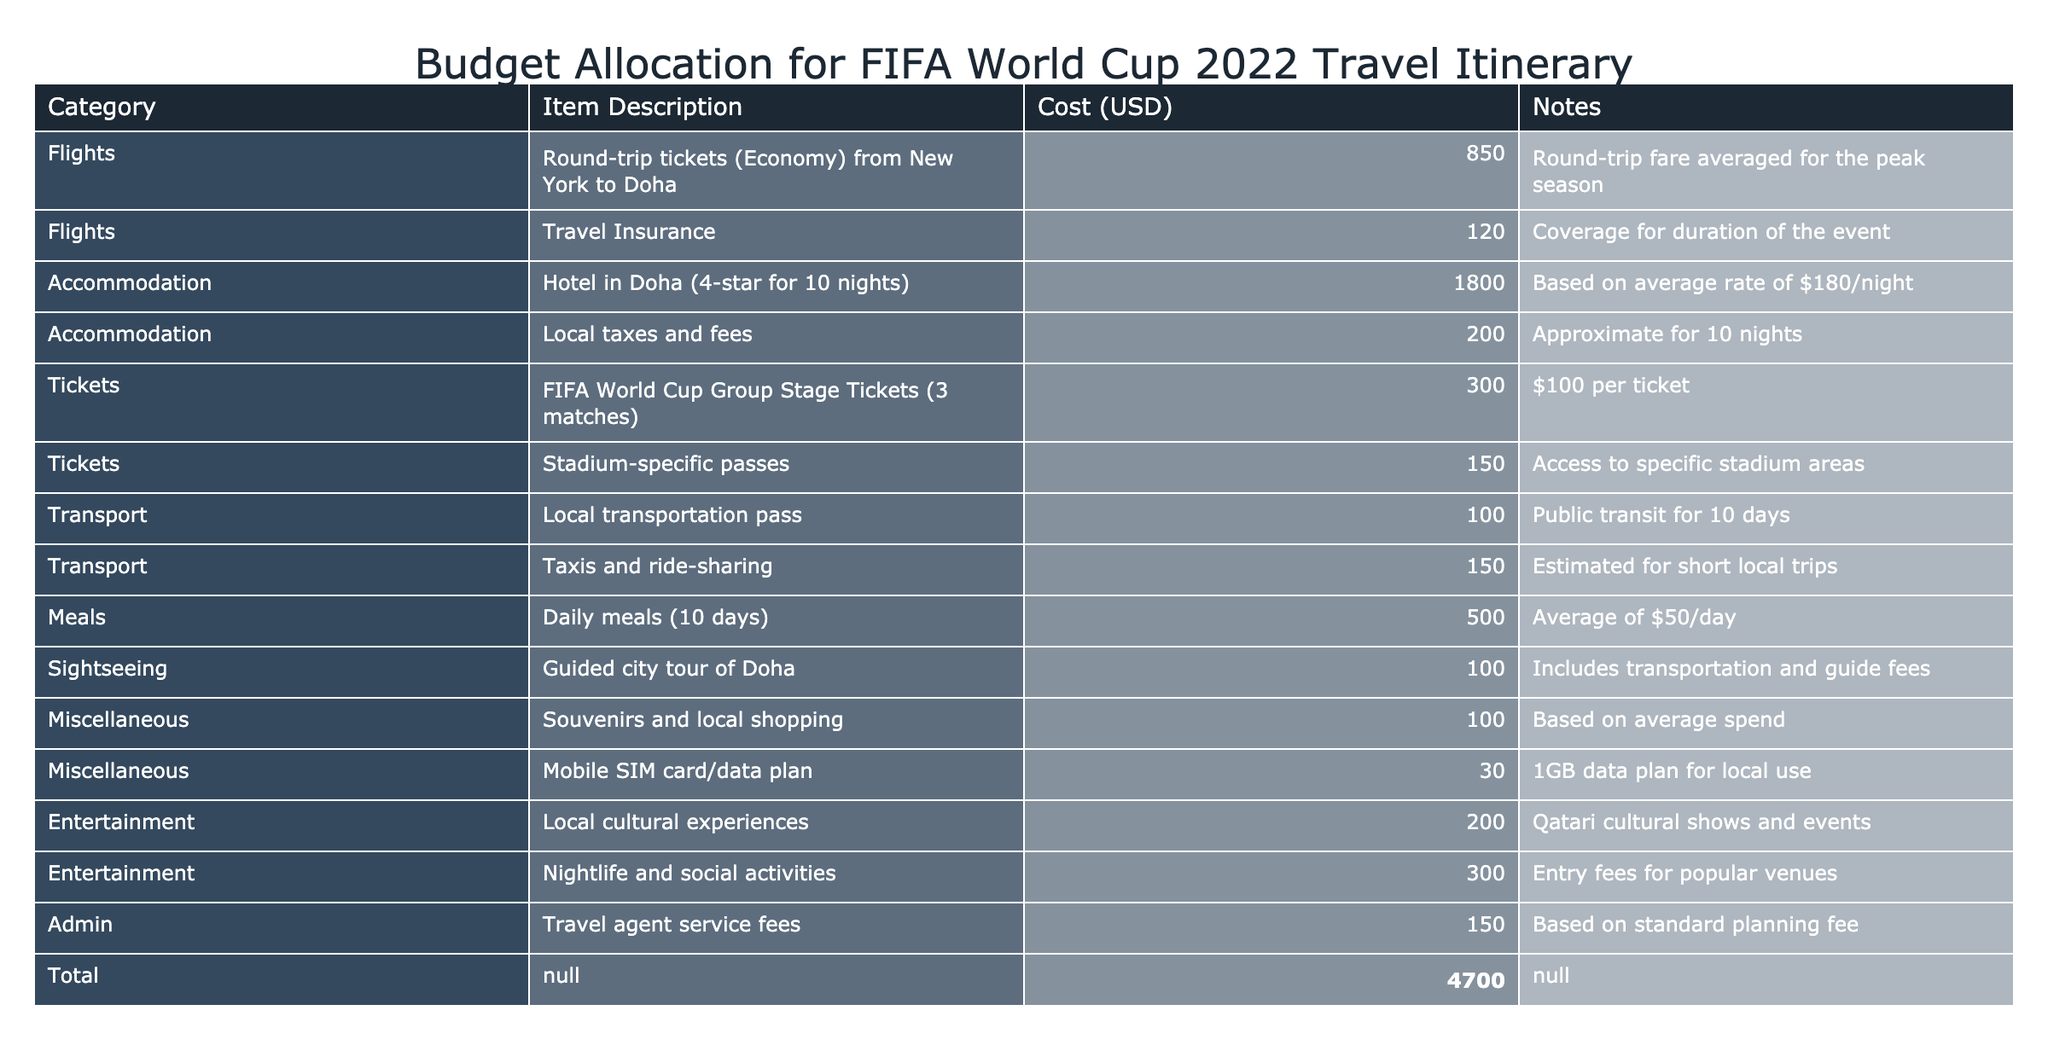What is the total cost for the travel itinerary? The total cost is listed in the last row of the table under the "Cost (USD)" column, which shows a total of $4700.
Answer: 4700 How much is allocated for flights in total? There are two entries for flights: round-trip tickets for $850 and travel insurance for $120. Adding these together gives $850 + $120 = $970.
Answer: 970 Are meals included in the budget? Yes, there is a line item for daily meals totaling $500.
Answer: Yes What is the combined cost of accommodation and transport? The accommodation totals $2000 (hotel plus local taxes and fees) and transport totals $250 (public transit pass plus taxis and ride-sharing). Adding these gives $2000 + $250 = $2250.
Answer: 2250 Is the cost for entertainment greater than the total for tickets? The entertainment totals $500 (local cultural experiences for $200 and nightlife activities for $300), while the ticket cost is $450 (group stage tickets and passes combined). Since $500 is greater than $450, the answer is yes.
Answer: Yes What percentage of the total budget is spent on accommodation? Accommodation costs $2000 out of a total of $4700. To find the percentage, divide $2000 by $4700 and multiply by 100: ($2000 / $4700) * 100 ≈ 42.55%.
Answer: Approximately 42.55% What is the cost difference between the cheapest and the most expensive item in the budget? The cheapest item is the mobile SIM card/data plan for $30, and the most expensive item is the hotel accommodation for $1800. The difference is $1800 - $30 = $1770.
Answer: 1770 How much is budgeted for sightseeing activities? The table lists the guided city tour of Doha at a cost of $100, indicating that this is the total allocated for sightseeing activities.
Answer: 100 What is the average cost per day for meals based on the budget provided? Daily meals for 10 days total $500. To find the average cost per day, divide $500 by 10 days: $500 / 10 = $50 per day.
Answer: 50 